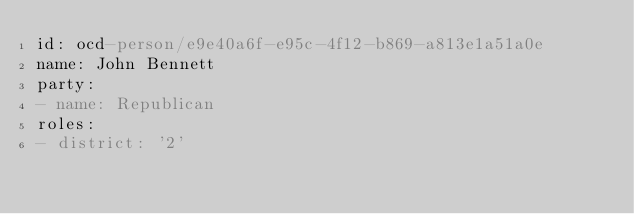<code> <loc_0><loc_0><loc_500><loc_500><_YAML_>id: ocd-person/e9e40a6f-e95c-4f12-b869-a813e1a51a0e
name: John Bennett
party:
- name: Republican
roles:
- district: '2'</code> 